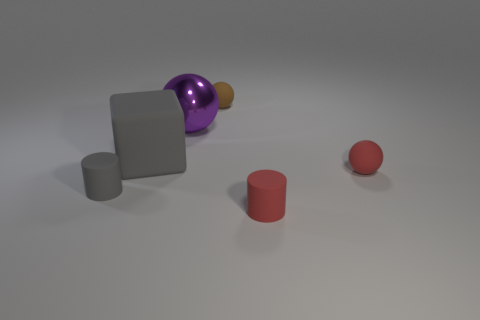Do the large object that is left of the large sphere and the big metal thing have the same shape?
Provide a short and direct response. No. Is the number of metallic things that are in front of the large matte object less than the number of tiny green rubber cylinders?
Offer a very short reply. No. Is there a cube that has the same color as the large metal ball?
Make the answer very short. No. Is the shape of the tiny gray thing the same as the red rubber thing that is in front of the tiny red matte sphere?
Your response must be concise. Yes. Is there a big sphere that has the same material as the brown object?
Provide a succinct answer. No. There is a tiny rubber sphere on the right side of the cylinder to the right of the big shiny ball; is there a matte block behind it?
Ensure brevity in your answer.  Yes. What number of other objects are there of the same shape as the metallic thing?
Offer a very short reply. 2. There is a big thing that is on the right side of the block that is to the left of the small matte cylinder that is right of the purple metal sphere; what color is it?
Provide a succinct answer. Purple. How many tiny green cubes are there?
Provide a short and direct response. 0. What number of large objects are either red balls or red matte cylinders?
Your answer should be very brief. 0. 